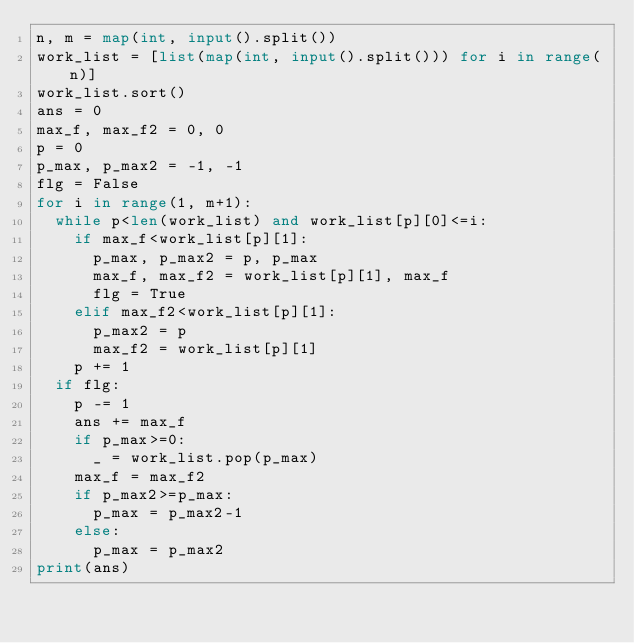Convert code to text. <code><loc_0><loc_0><loc_500><loc_500><_Python_>n, m = map(int, input().split())
work_list = [list(map(int, input().split())) for i in range(n)]
work_list.sort()
ans = 0
max_f, max_f2 = 0, 0
p = 0
p_max, p_max2 = -1, -1
flg = False
for i in range(1, m+1):
  while p<len(work_list) and work_list[p][0]<=i:
    if max_f<work_list[p][1]:
      p_max, p_max2 = p, p_max
      max_f, max_f2 = work_list[p][1], max_f
      flg = True
    elif max_f2<work_list[p][1]:
      p_max2 = p
      max_f2 = work_list[p][1]
    p += 1
  if flg:
    p -= 1
    ans += max_f
    if p_max>=0:
      _ = work_list.pop(p_max)
    max_f = max_f2
    if p_max2>=p_max:
      p_max = p_max2-1
    else:
      p_max = p_max2
print(ans)</code> 